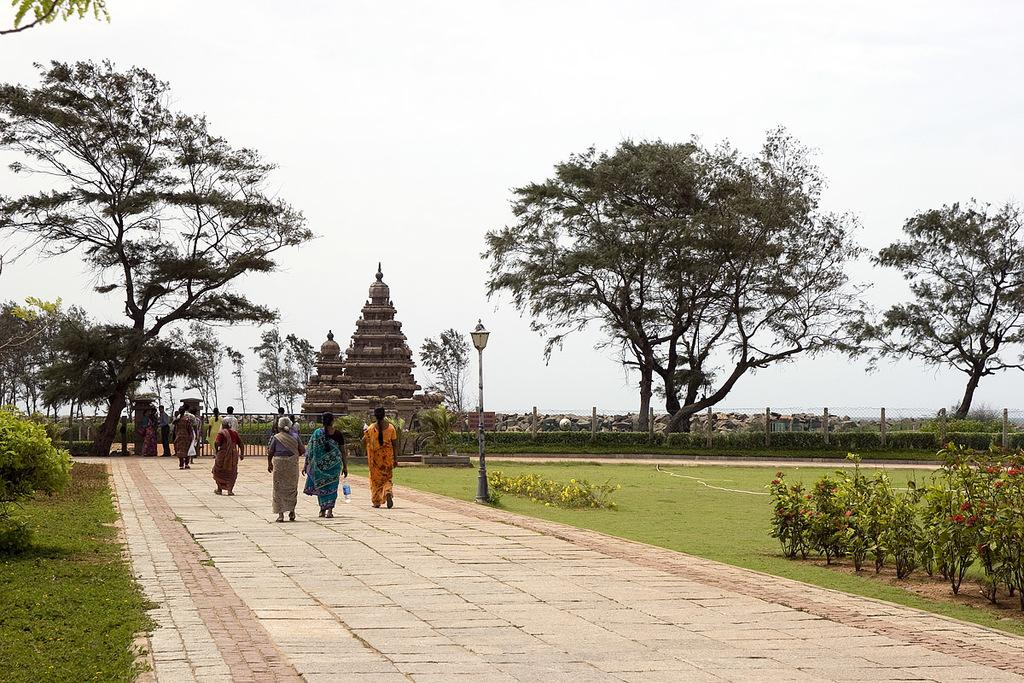What can be seen in the image that people might walk on? There is a path in the image that people are walking on. What else is present in the image besides the path? There is a garden in the image. What can be seen in the background of the image? There is a temple and trees in the background of the image, as well as the sky. What type of letter is being sung by the people walking on the path in the image? There is no indication in the image that people are singing a letter or any songs; they are simply walking on the path. 